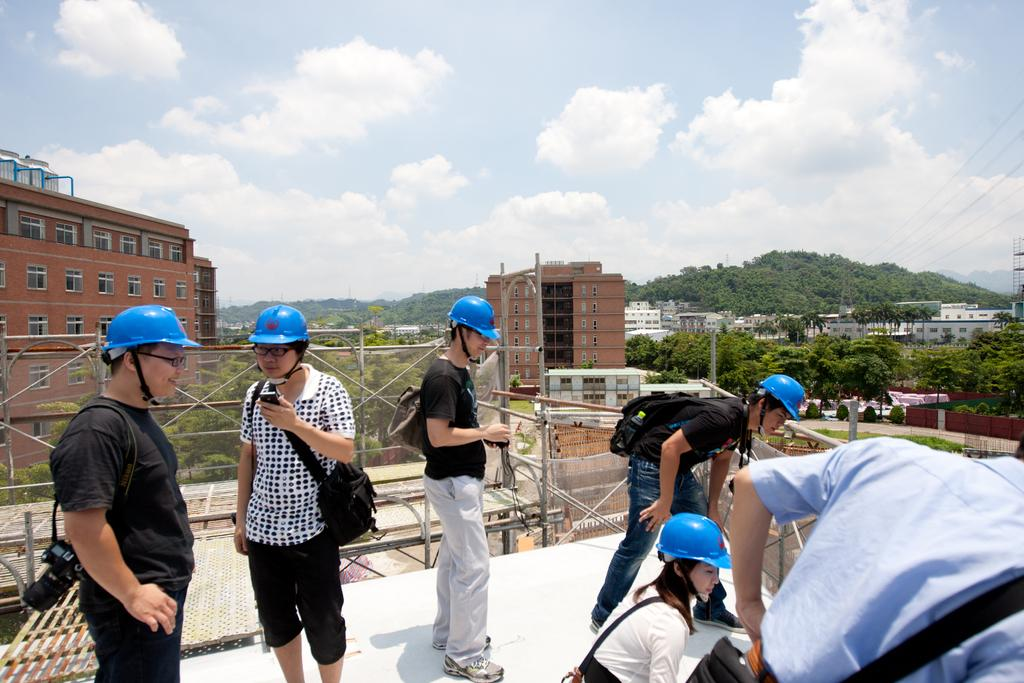What is the weather like in the image? The sky is cloudy in the image. What type of structures can be seen in the image? There are buildings with windows in the image. What type of vegetation is present in the image? There are trees in the image. What type of protective gear are some people wearing in the image? There are people wearing helmets in the image. What is the man holding in the image? A man is wearing a bag and holding a mobile in the image. What type of guitar can be seen in the library in the image? There is no guitar or library present in the image. What type of poison is being used by the people in the image? There is no mention of poison or any dangerous substances in the image. 